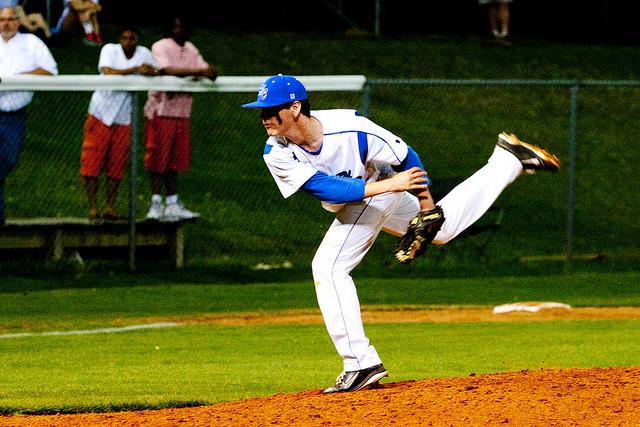What sport is he playing here?
Be succinct. Baseball. How many pairs of red shorts do we see?
Quick response, please. 2. Are any of the spectators wearing baseball caps?
Short answer required. No. Is there an audience?
Be succinct. Yes. 